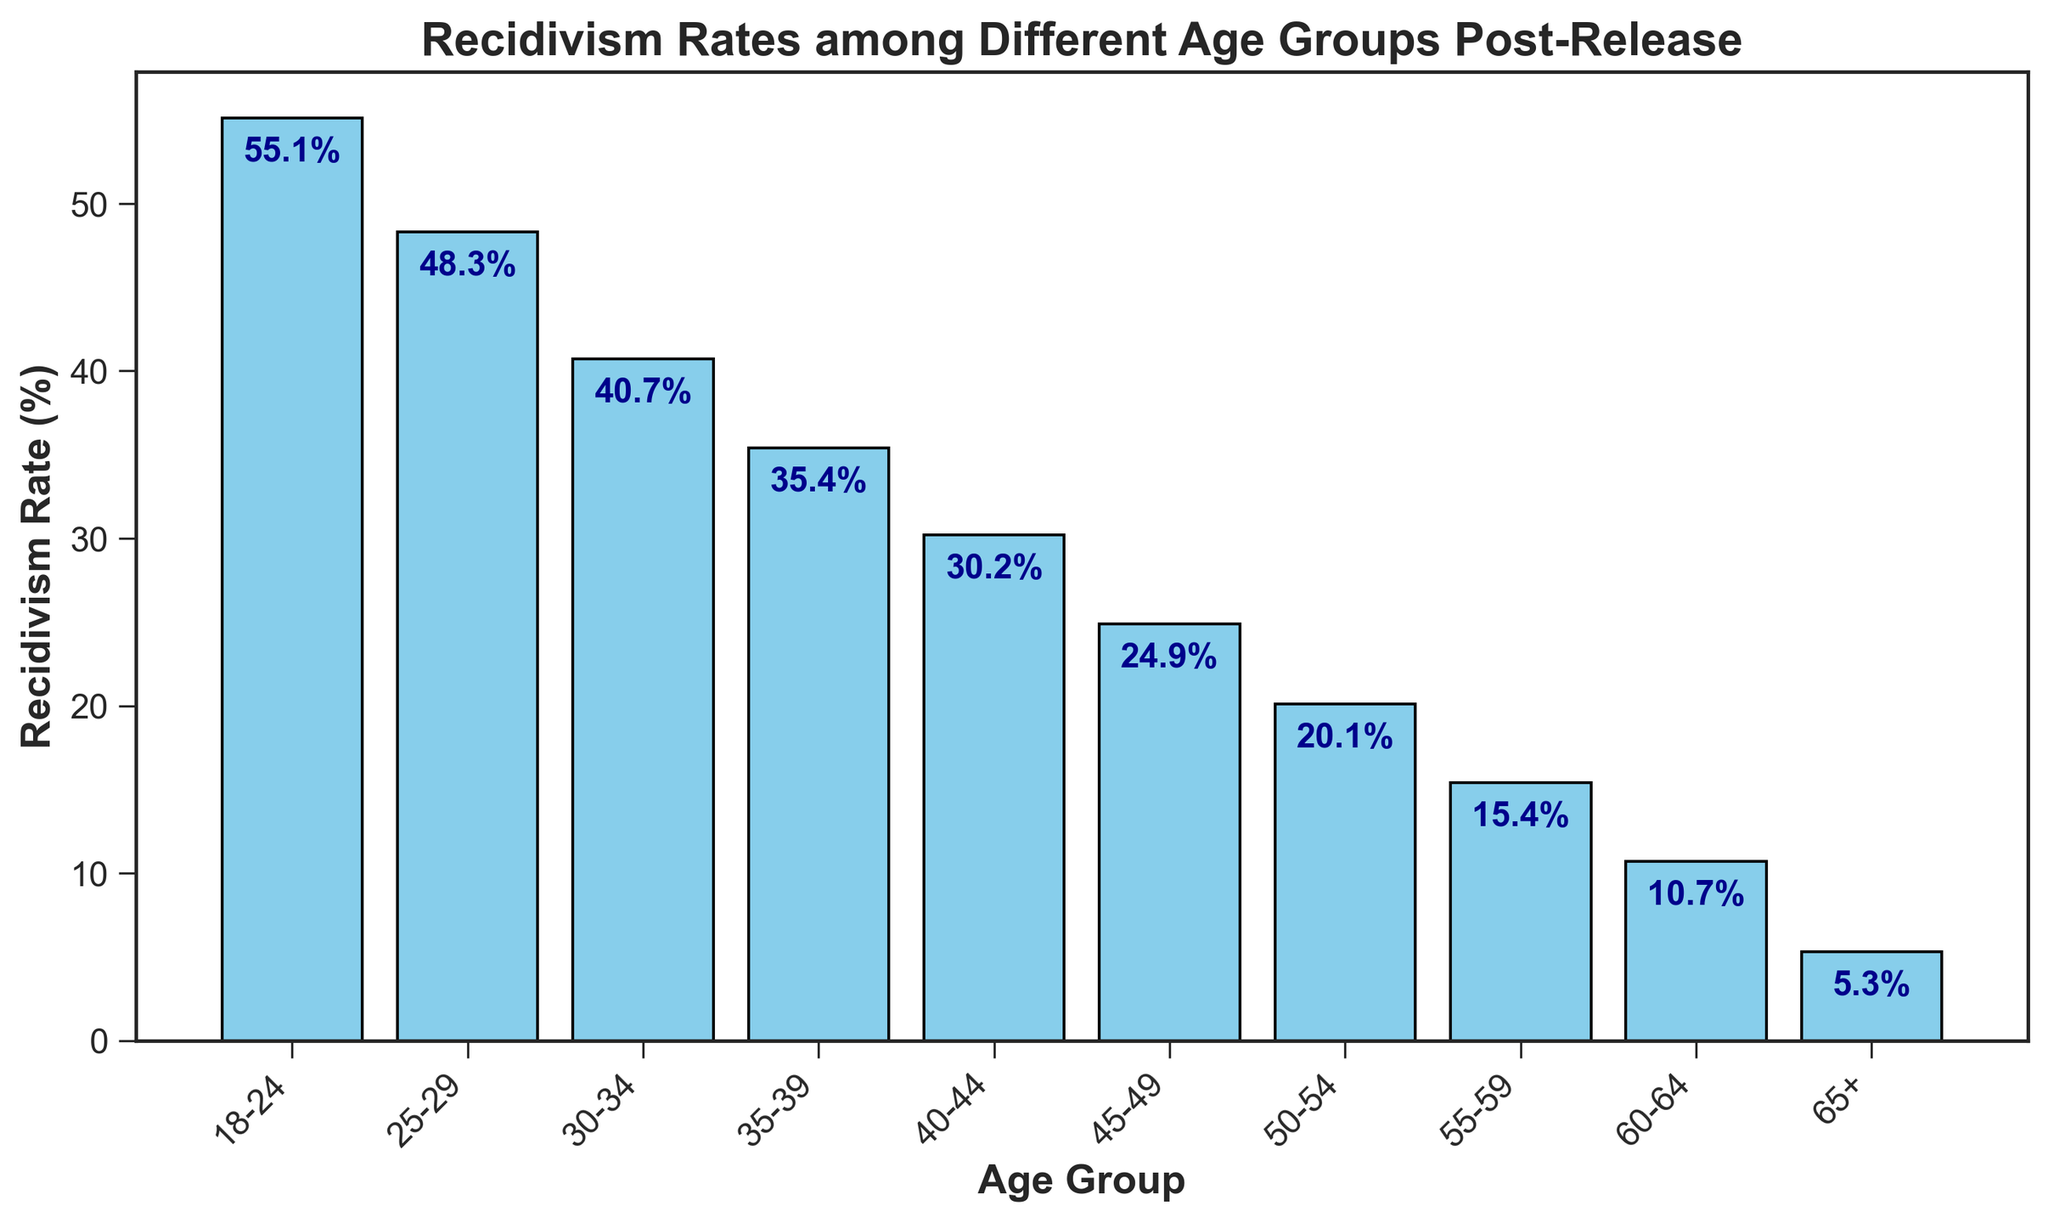Which age group has the highest recidivism rate? By looking at the tallest bar in the histogram, we can see that the age group "18-24" has the highest recidivism rate.
Answer: 18-24 Which age group has the lowest recidivism rate? The shortest bar in the histogram represents the age group "65+", indicating it has the lowest recidivism rate.
Answer: 65+ By how much does the recidivism rate decrease from the '18-24' age group to the '25-29' age group? The recidivism rate for '18-24' is 55.1% and for '25-29' it is 48.3%. Therefore, 55.1 - 48.3 = 6.8%.
Answer: 6.8% What is the average recidivism rate for the age groups under 40 years? The age groups under 40 years are '18-24', '25-29', '30-34', and '35-39'. Their rates are 55.1, 48.3, 40.7, and 35.4. The average is (55.1 + 48.3 + 40.7 + 35.4) / 4 = 44.875%.
Answer: 44.875% Which age group has a recidivism rate closest to 20%? The bar for '50-54' has a recidivism rate of 20.1%, which is closest to 20% compared to other age groups.
Answer: 50-54 Compare the recidivism rates between the 35-39 and 50-54 age groups. Which is higher and by how much? The rate for '35-39' is 35.4% and for '50-54' is 20.1%. Therefore, 35.4 - 20.1 = 15.3%. The rate for '35-39' is higher by 15.3%.
Answer: 35-39; 15.3% What is the combined recidivism rate for the age groups 40-44 and 45-49? The rates for '40-44' and '45-49' are 30.2% and 24.9%, respectively. The combined rate is 30.2 + 24.9 = 55.1%.
Answer: 55.1% What is the median recidivism rate for all age groups listed? Listing all rates: 55.1, 48.3, 40.7, 35.4, 30.2, 24.9, 20.1, 15.4, 10.7, and 5.3. In order: 5.3, 10.7, 15.4, 20.1, 24.9, 30.2, 35.4, 40.7, 48.3, 55.1. The median is the average of the 5th and 6th values: (24.9+30.2)/2 = 27.55%.
Answer: 27.55% 